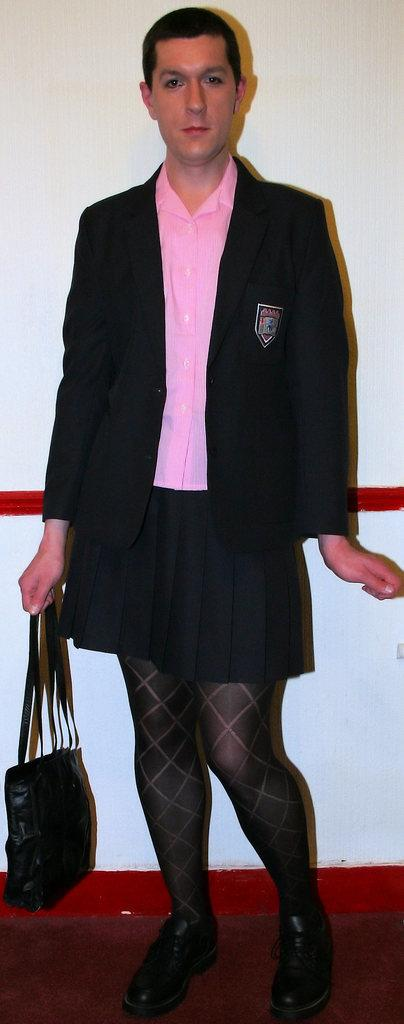What is the main subject of the image? There is a person in the image. What type of clothing is the person wearing? The person is wearing a shirt, a coat, a skirt, and shoes. What is the person holding in their right hand? The person is holding a black color bag in their right hand. What is the color of the floor in the image? The floor in the image is brown. What is the color of the wall in the image? The wall in the image is white. How many patches can be seen on the yak in the image? There is no yak present in the image, so there are no patches to count. 